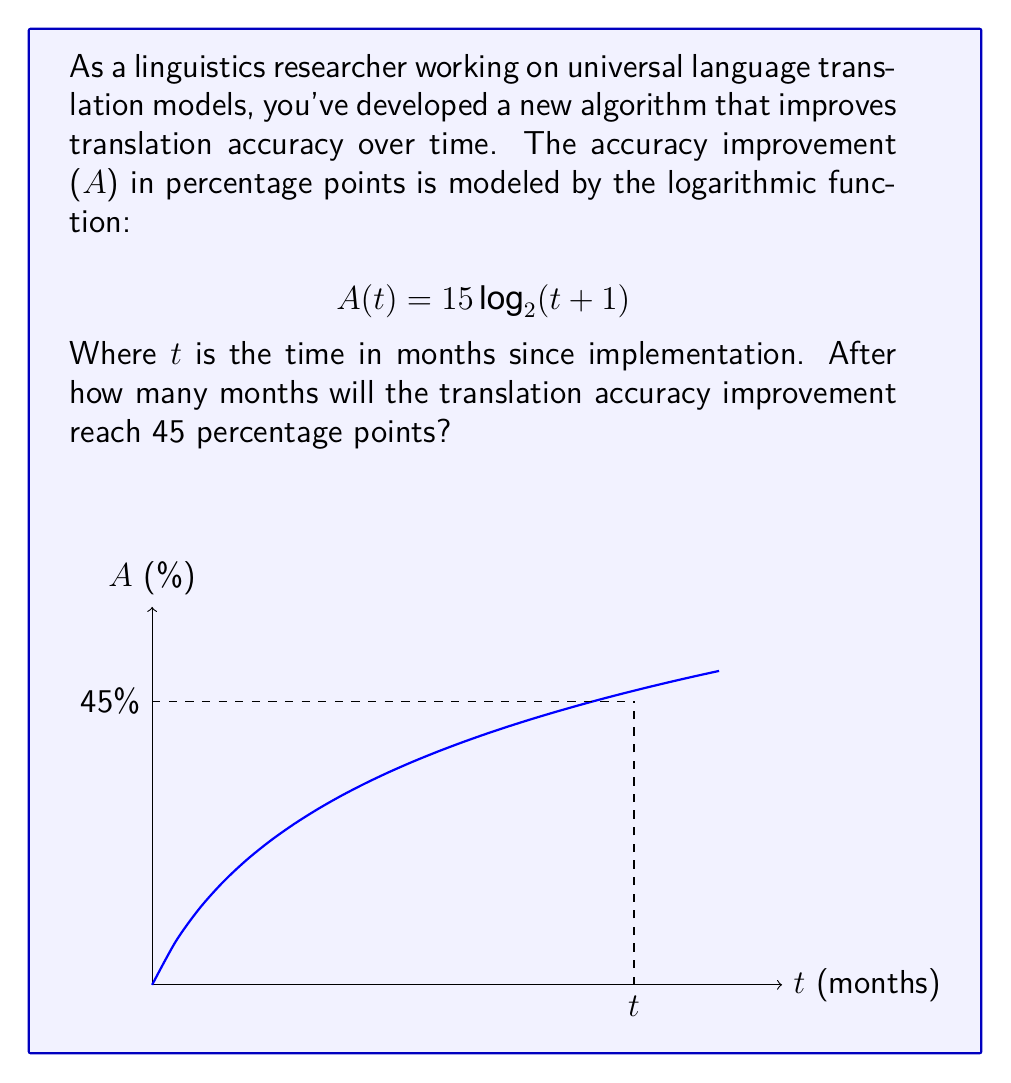Help me with this question. Let's approach this step-by-step:

1) We need to solve the equation:
   $$45 = 15 \log_2(t + 1)$$

2) Divide both sides by 15:
   $$3 = \log_2(t + 1)$$

3) To solve for t, we need to apply the inverse function of $\log_2$, which is $2^x$:
   $$2^3 = t + 1$$

4) Simplify:
   $$8 = t + 1$$

5) Subtract 1 from both sides:
   $$7 = t$$

6) Therefore, the accuracy improvement will reach 45 percentage points after 7 months.

7) To verify:
   $$A(7) = 15 \log_2(7 + 1) = 15 \log_2(8) = 15 * 3 = 45$$

This confirms our solution.
Answer: 7 months 